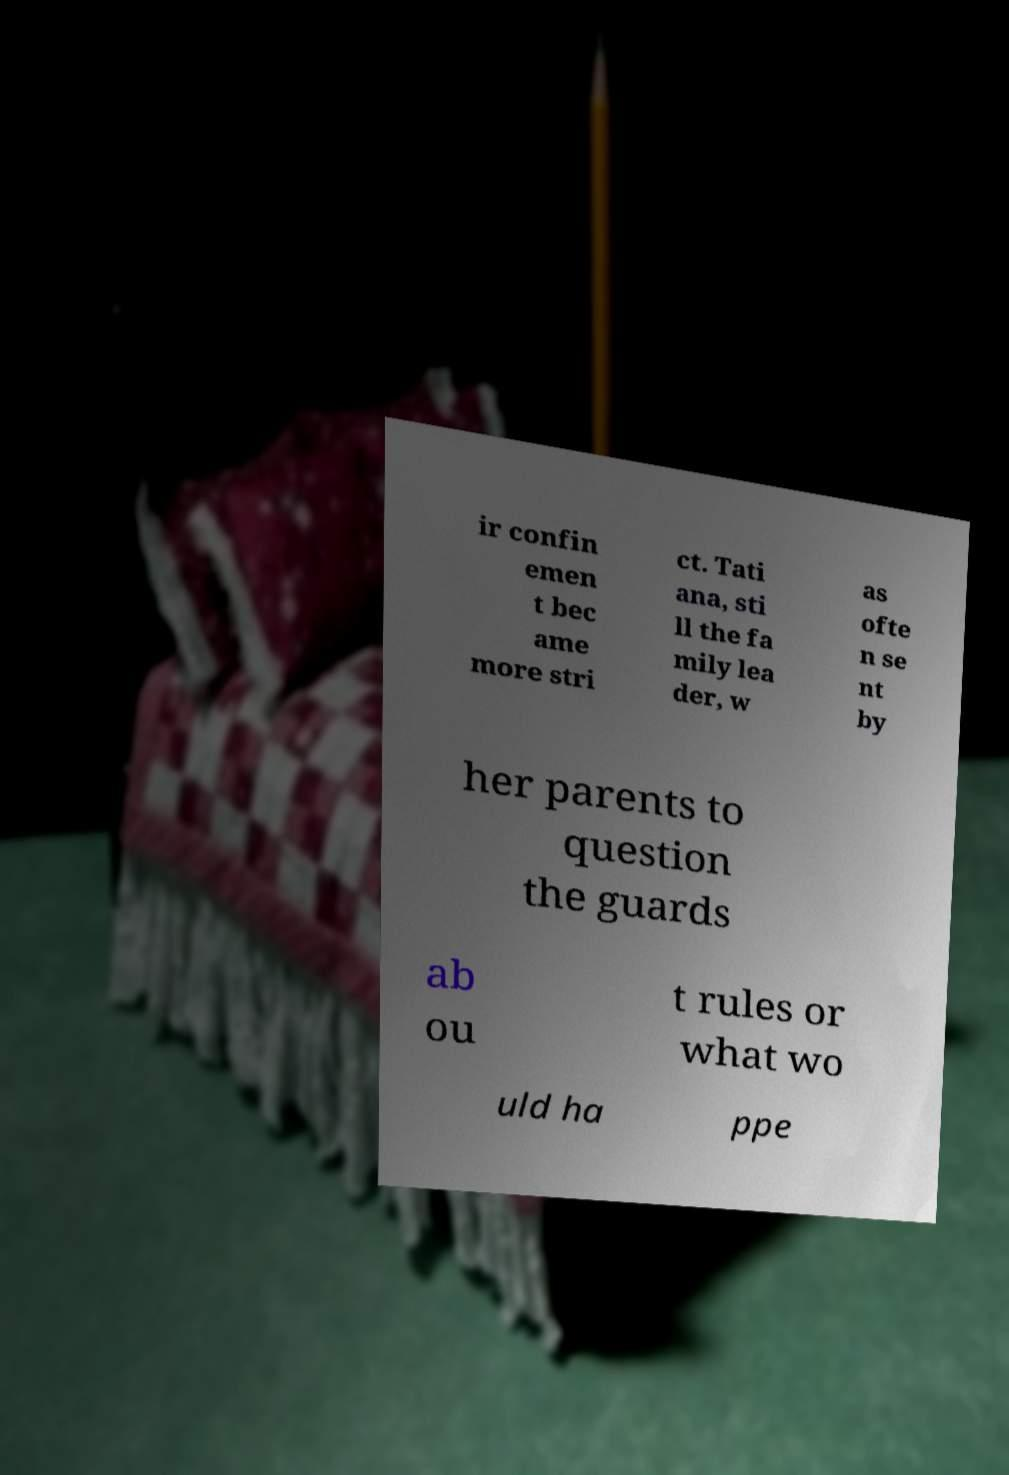I need the written content from this picture converted into text. Can you do that? ir confin emen t bec ame more stri ct. Tati ana, sti ll the fa mily lea der, w as ofte n se nt by her parents to question the guards ab ou t rules or what wo uld ha ppe 